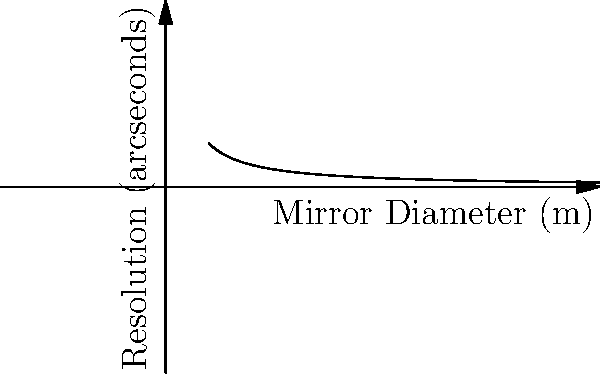A proposed space telescope has a mirror diameter of 3 meters, providing a resolution of 1/3 arcseconds (point A on the graph). If the mirror diameter is doubled to 6 meters (point B), how does the resolution change? Express your answer as a fraction of the original resolution. To solve this problem, we need to understand the relationship between telescope mirror diameter and resolution. The resolution of a telescope is inversely proportional to its mirror diameter. This relationship is represented by the equation:

$$R \propto \frac{1}{D}$$

Where $R$ is the resolution and $D$ is the mirror diameter.

Let's approach this step-by-step:

1) Initially, we have:
   $D_1 = 3$ m, $R_1 = \frac{1}{3}$ arcseconds

2) After doubling the mirror diameter:
   $D_2 = 6$ m, $R_2 = ?$

3) We can set up a proportion:
   $$\frac{R_1}{R_2} = \frac{D_2}{D_1}$$

4) Substituting the known values:
   $$\frac{1/3}{R_2} = \frac{6}{3} = 2$$

5) Solving for $R_2$:
   $$R_2 = \frac{1/3}{2} = \frac{1}{6}$$ arcseconds

6) To express this as a fraction of the original resolution:
   $$\frac{R_2}{R_1} = \frac{1/6}{1/3} = \frac{1}{2}$$

Therefore, the new resolution is 1/2 of the original resolution.
Answer: $\frac{1}{2}$ 